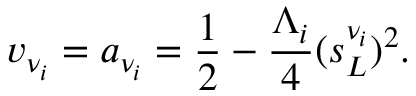<formula> <loc_0><loc_0><loc_500><loc_500>v _ { \nu _ { i } } = a _ { \nu _ { i } } = { \frac { 1 } { 2 } } - { \frac { \Lambda _ { i } } { 4 } } ( s _ { L } ^ { \nu _ { i } } ) ^ { 2 } .</formula> 